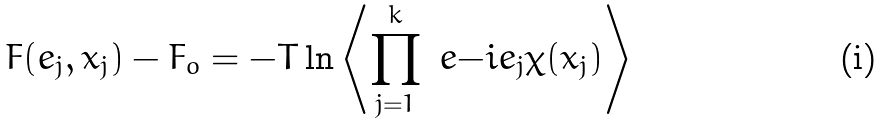Convert formula to latex. <formula><loc_0><loc_0><loc_500><loc_500>F ( e _ { j } , x _ { j } ) - F _ { o } = - T \ln \left \langle \prod _ { j = 1 } ^ { k } \ e { - i e _ { j } \chi ( x _ { j } ) } \right \rangle</formula> 